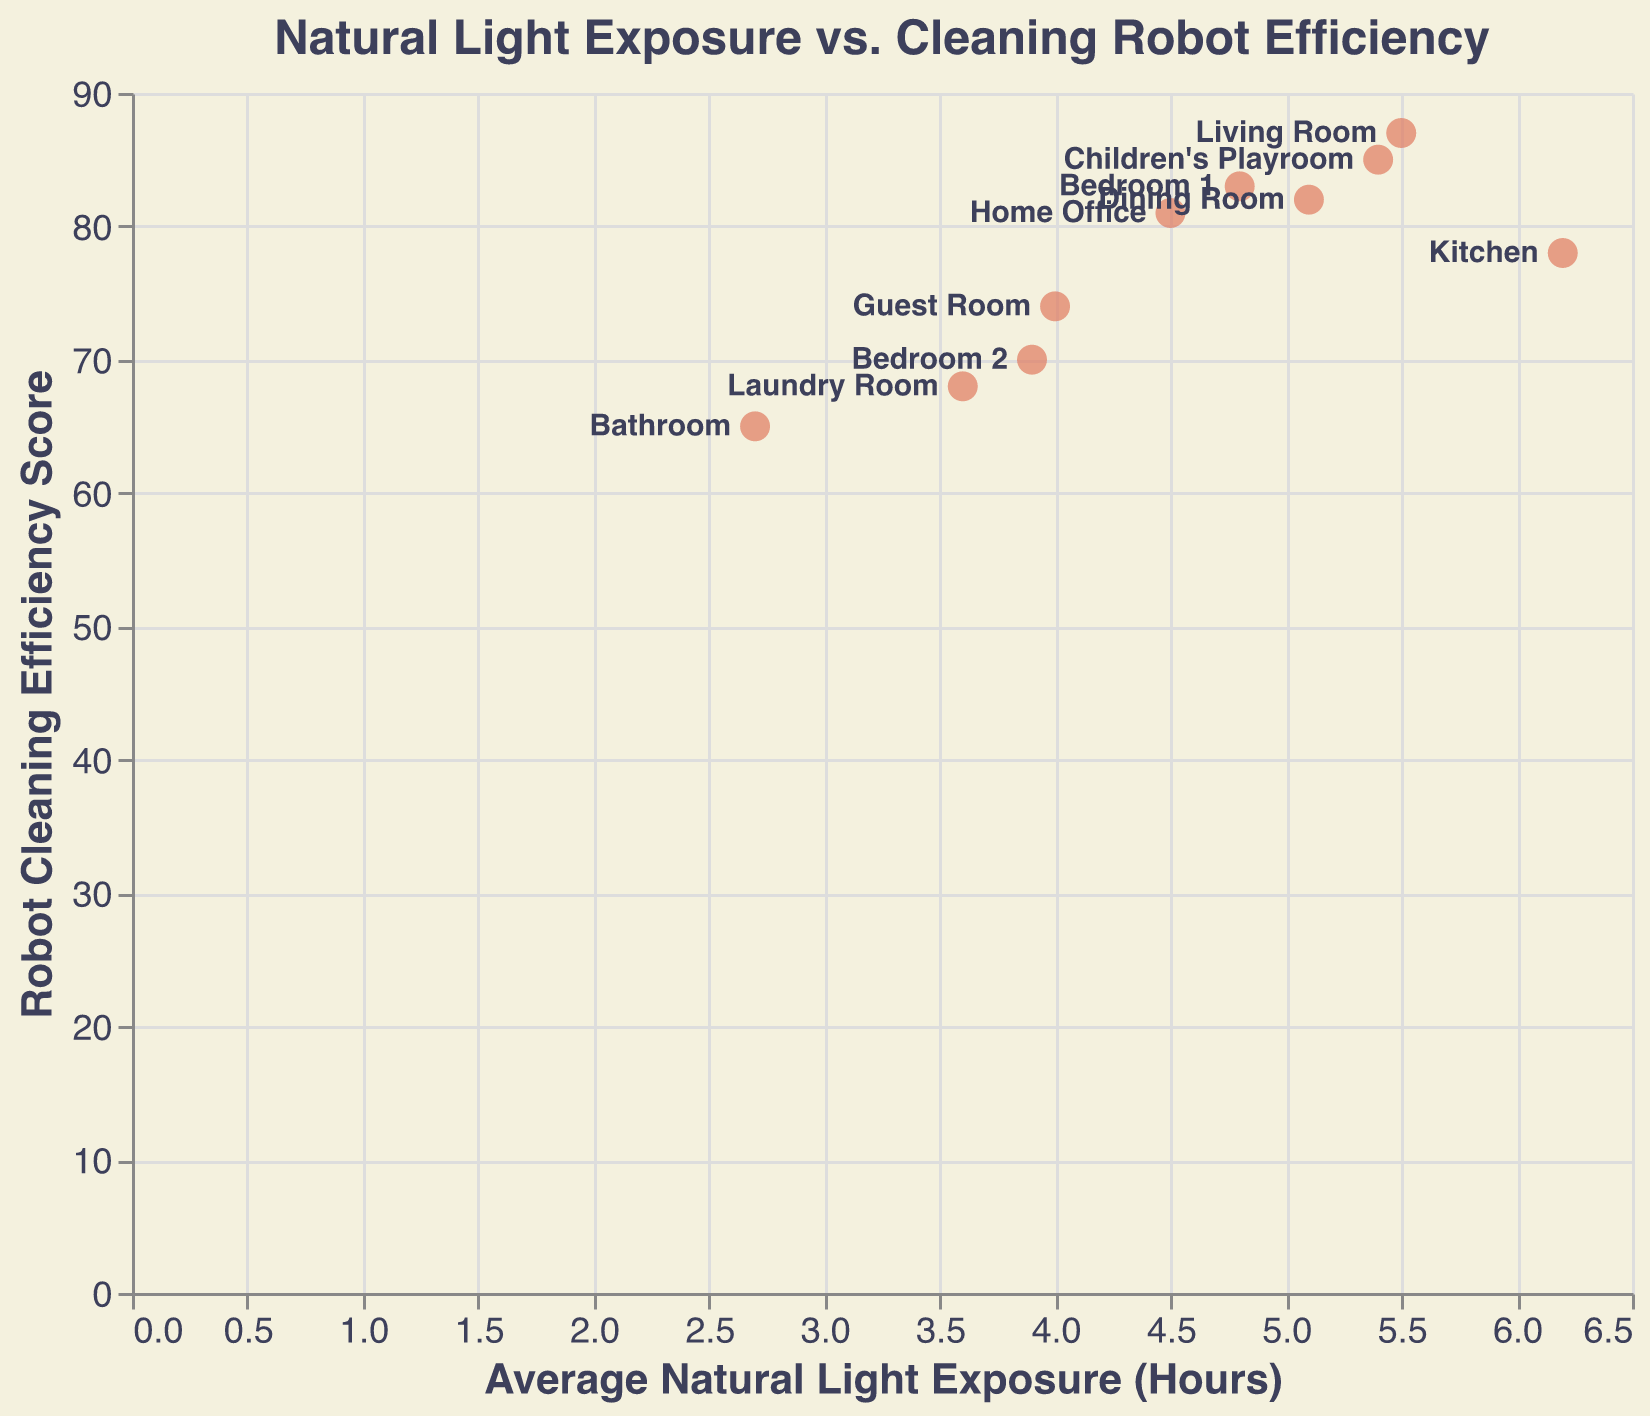What is the title of the plot? The title of the plot is written at the top of the figure in larger, bold text. It reads "Natural Light Exposure vs. Cleaning Robot Efficiency".
Answer: Natural Light Exposure vs. Cleaning Robot Efficiency What is the room with the lowest average natural light exposure? Look for the room with the smallest x-value, which is along the horizontal axis labeled "Average Natural Light Exposure (Hours)". The Bathroom has the lowest value at 2.7 hours.
Answer: Bathroom Which room has the highest robot cleaning efficiency score? Look for the room with the highest y-value on the vertical axis labeled "Robot Cleaning Efficiency Score". The Living Room has the highest score of 87.
Answer: Living Room How many rooms have an average natural light exposure greater than 5 hours? Identify the points on the plot where the x-value (average natural light exposure) is greater than 5 hours. There are four such points: Living Room (5.5), Kitchen (6.2), Dining Room (5.1), and Children's Playroom (5.4).
Answer: 4 Is there a correlation between natural light exposure and cleaning efficiency? Observe if there is a general trend in the scatter plot where higher natural light exposure aligns with higher cleaning efficiency scores. Although there is some variability, rooms with higher natural light exposure like the Living Room and Children's Playroom tend to have high cleaning efficiency scores.
Answer: Yes What is the difference in natural light exposure between the Kitchen and the Bathroom? Find the x-values for the Kitchen (6.2 hours) and the Bathroom (2.7 hours) and calculate the difference: 6.2 - 2.7.
Answer: 3.5 hours Which room has the lowest cleaning efficiency score and what is its natural light exposure? Identify the point with the lowest y-value, representing the lowest cleaning efficiency score. The Bathroom has the lowest score of 65 and its average natural light exposure is 2.7 hours.
Answer: Bathroom, 2.7 hours Do bedrooms generally have higher or lower natural light exposure compared to the average of other rooms? Calculate the average natural light exposure of all rooms. Compare the values of Bedroom 1 (4.8 hours) and Bedroom 2 (3.9 hours) to this average. The overall average natural light exposure is (5.5+6.2+4.8+3.9+5.1+2.7+4.5+5.4+4.0+3.6)/10 = 4.77 hours. Both bedrooms (4.8 and 3.9 hours) have exposure close to or below this average.
Answer: Lower or about the same What's the average cleaning efficiency score for rooms with natural light exposure below 4 hours? Identify the rooms with light exposure below 4 hours: Bedroom 2 (3.9), Bathroom (2.7), Guest Room (4.0), Laundry Room (3.6). Calculate the average of their scores: (70 + 65 + 74 + 68)/4 = 69.25.
Answer: 69.25 